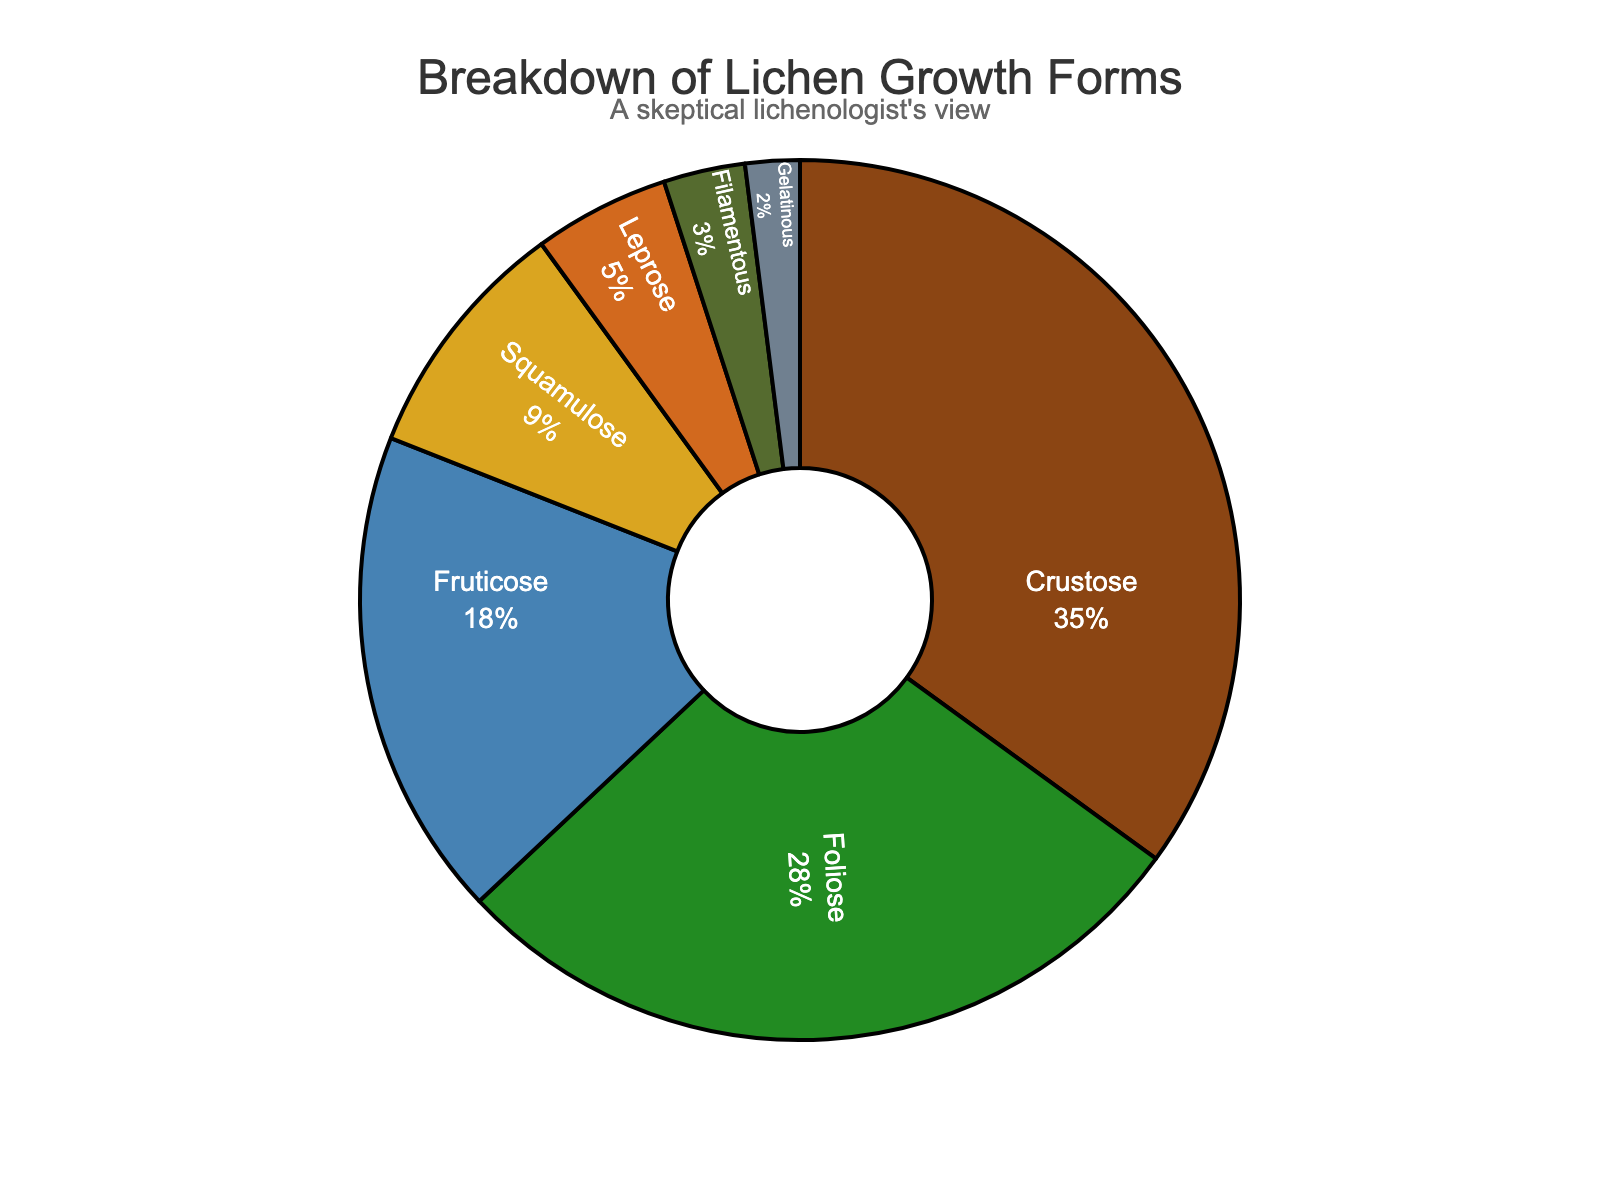Which growth form has the largest percentage? The growth form with the largest percentage is the one occupying the biggest segment in the pie chart. The segment labeled 'Crustose' is the largest.
Answer: Crustose What is the combined percentage of Foliose and Fruticose growth forms? To find the combined percentage, add the percentages of Foliose (28%) and Fruticose (18%). 28 + 18 = 46
Answer: 46 Is the percentage of Squamulose growth forms greater than the percentage of Leprose growth forms? Compare the percentages of Squamulose (9%) and Leprose (5%). Since 9 is greater than 5, Squamulose has a higher percentage.
Answer: Yes How much higher is the percentage of Crustose compared to Filamentous growth forms? Subtract the percentage of Filamentous (3%) from the percentage of Crustose (35%). 35 - 3 = 32
Answer: 32 What growth form has the smallest percentage, and what is its value? The smallest segment in the pie chart corresponds to the growth form labeled 'Gelatinous' with a percentage of 2%.
Answer: Gelatinous, 2 Which growth forms together make up more than half of the chart? Add the percentages of the growth forms starting from the largest until the sum exceeds 50%. Crustose (35%) + Foliose (28%) = 63%. Just these two exceed 50%.
Answer: Crustose, Foliose What is the difference in percentage between the Foliose and Squamulose growth forms? Subtract the percentage of Squamulose (9%) from the percentage of Foliose (28%). 28 - 9 = 19
Answer: 19 Are the sum percentages of Leprose, Filamentous, and Gelatinous growth forms more than 10%? Add the percentages of Leprose (5%), Filamentous (3%), and Gelatinous (2%). 5 + 3 + 2 = 10.
Answer: No 